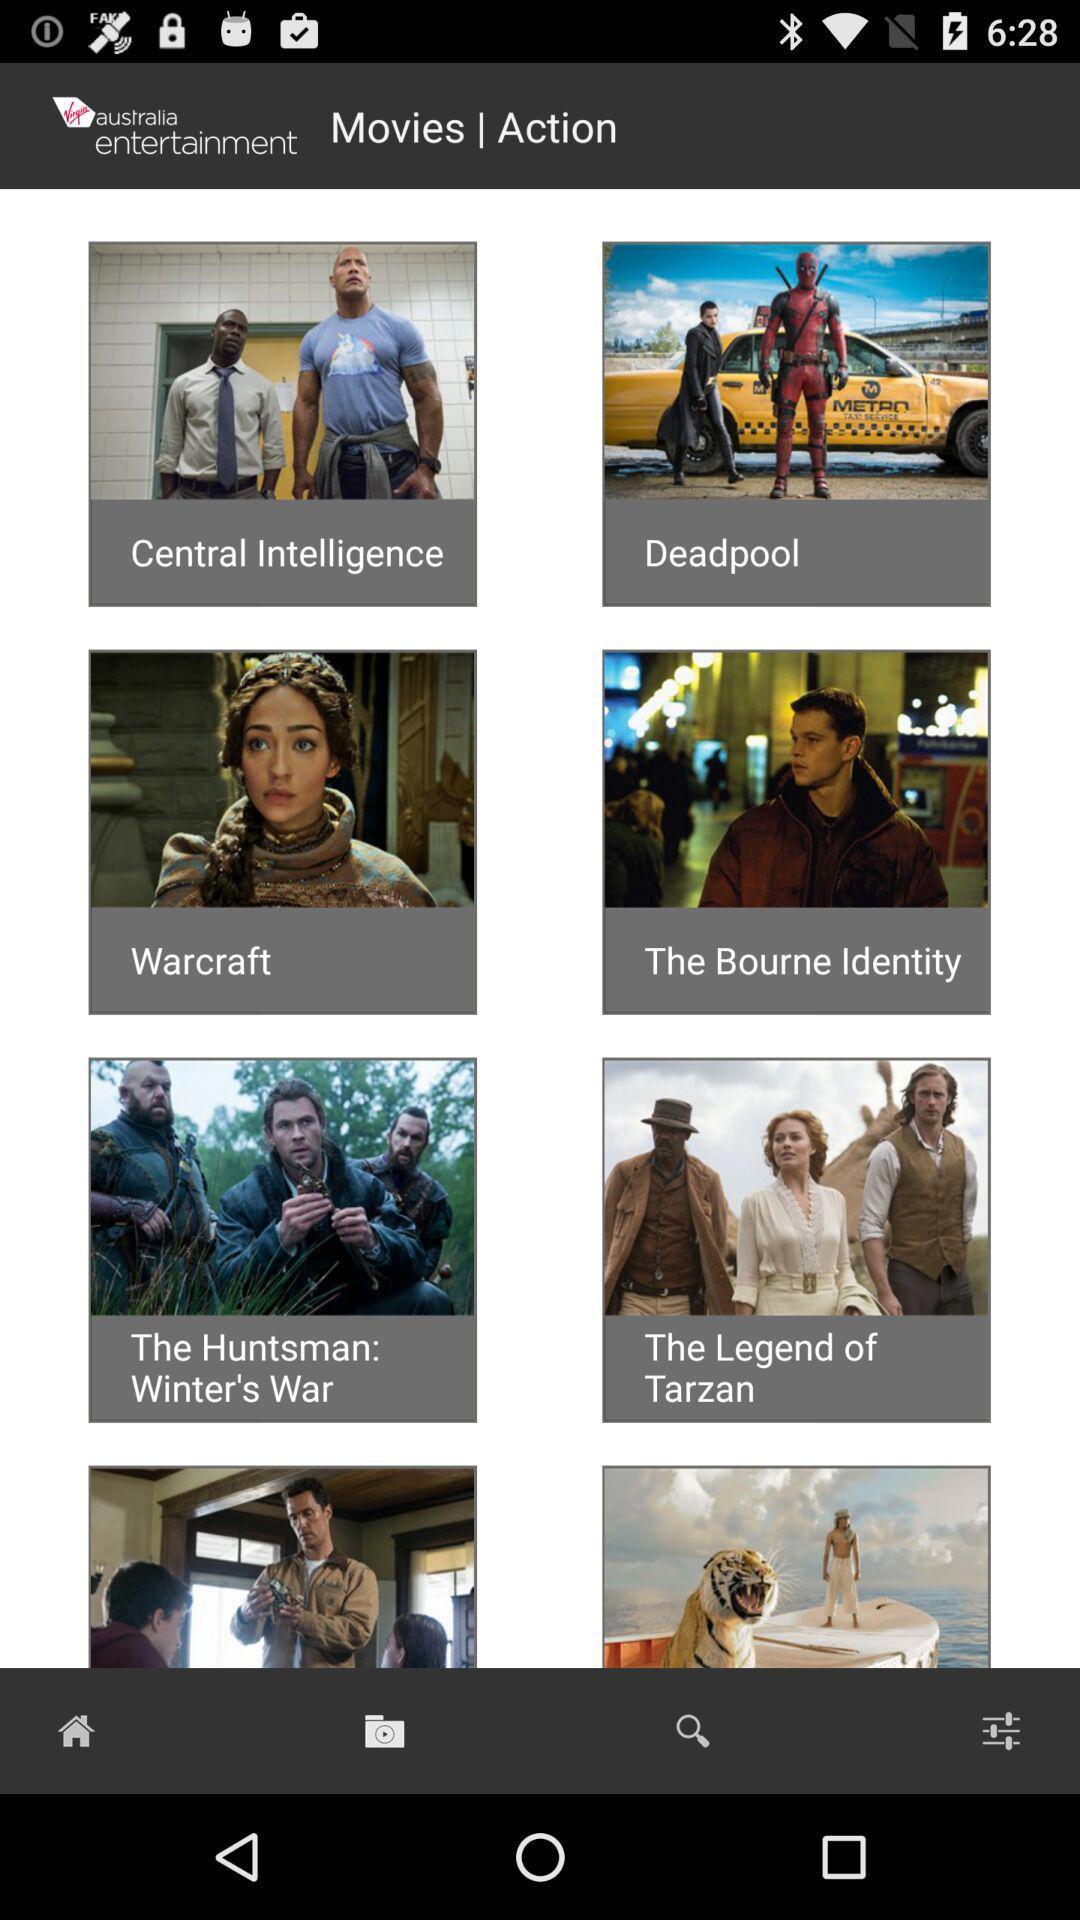What genre of movie is "The Notebook"?
When the provided information is insufficient, respond with <no answer>. <no answer> 